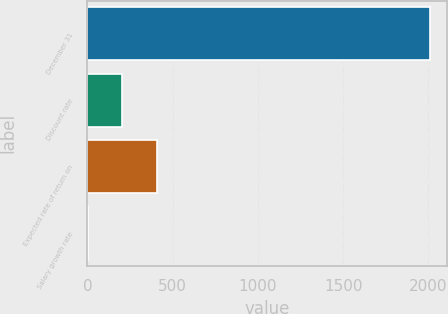<chart> <loc_0><loc_0><loc_500><loc_500><bar_chart><fcel>December 31<fcel>Discount rate<fcel>Expected rate of return on<fcel>Salary growth rate<nl><fcel>2009<fcel>204.95<fcel>405.4<fcel>4.5<nl></chart> 